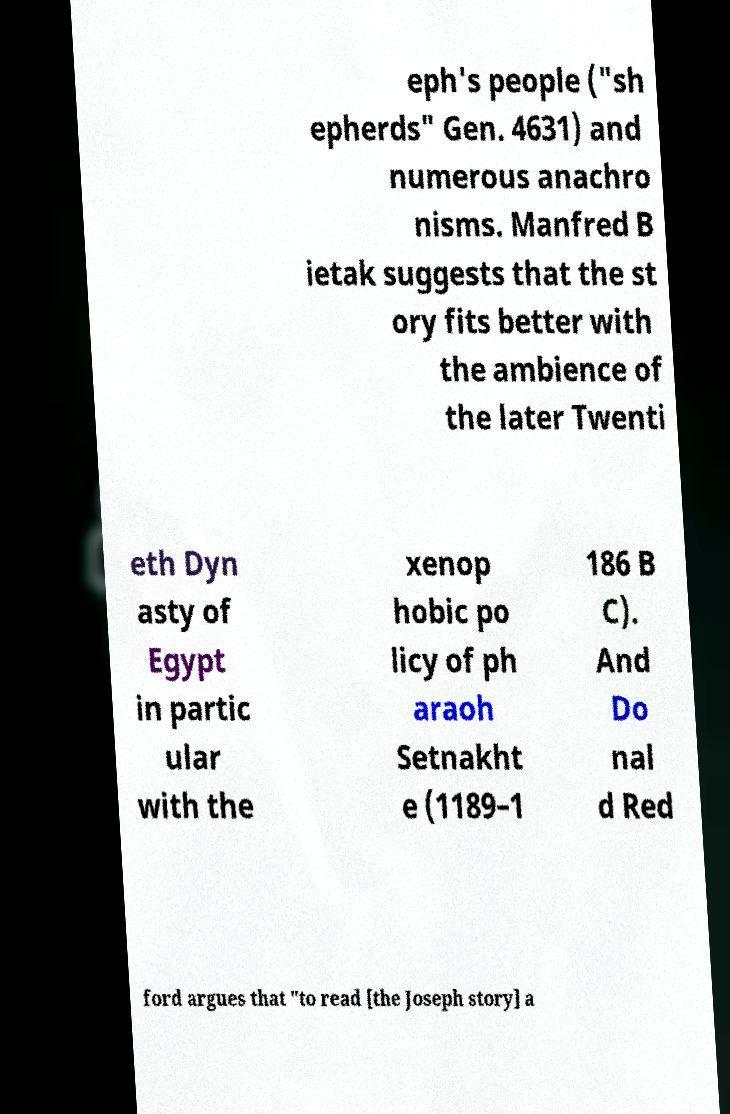Please identify and transcribe the text found in this image. eph's people ("sh epherds" Gen. 4631) and numerous anachro nisms. Manfred B ietak suggests that the st ory fits better with the ambience of the later Twenti eth Dyn asty of Egypt in partic ular with the xenop hobic po licy of ph araoh Setnakht e (1189–1 186 B C). And Do nal d Red ford argues that "to read [the Joseph story] a 